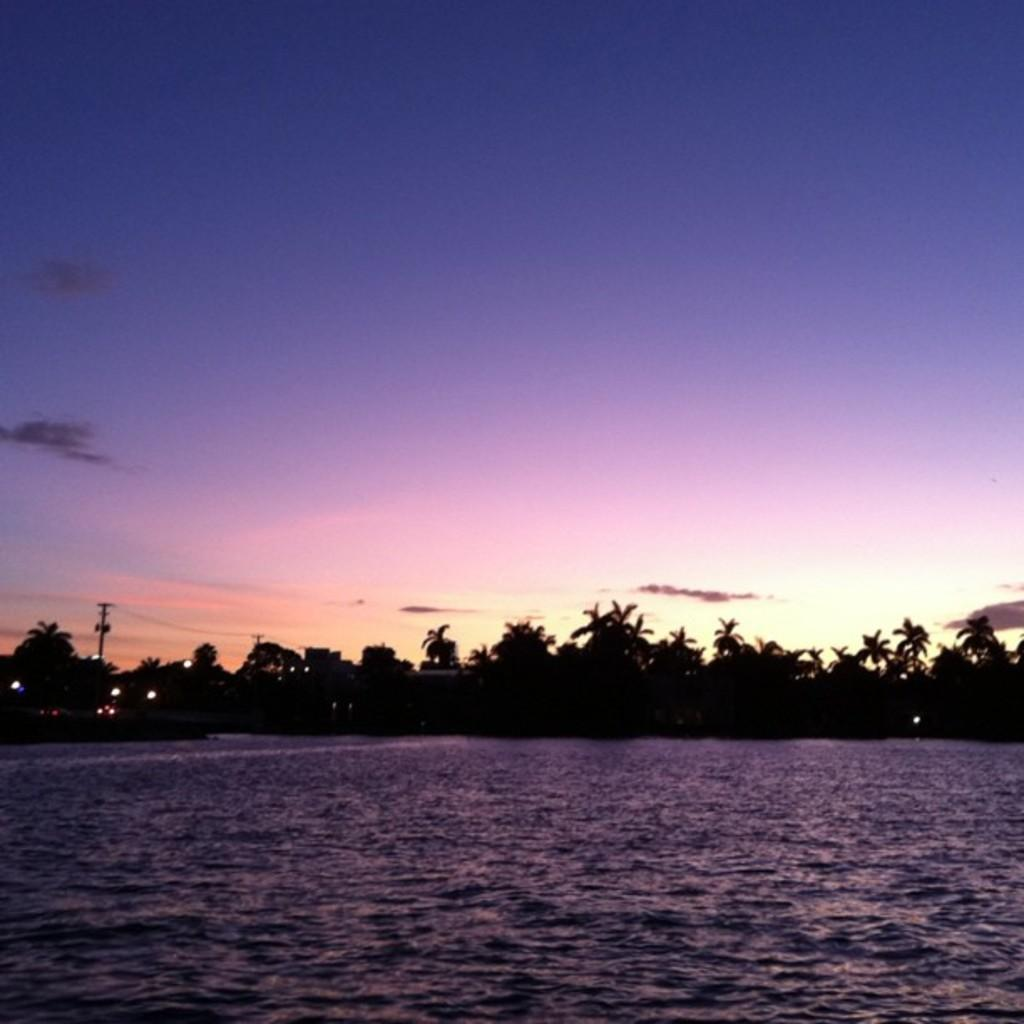Where was the image taken? The image was clicked outside the city. What can be seen in the foreground of the image? There is a water body in the foreground of the image. What can be seen in the background of the image? There is a ski, a pole, trees, and lights in the background of the image. What items are on the list in the image? There is no list present in the image. Can you tell me how many horses are visible in the image? There are no horses visible in the image. 